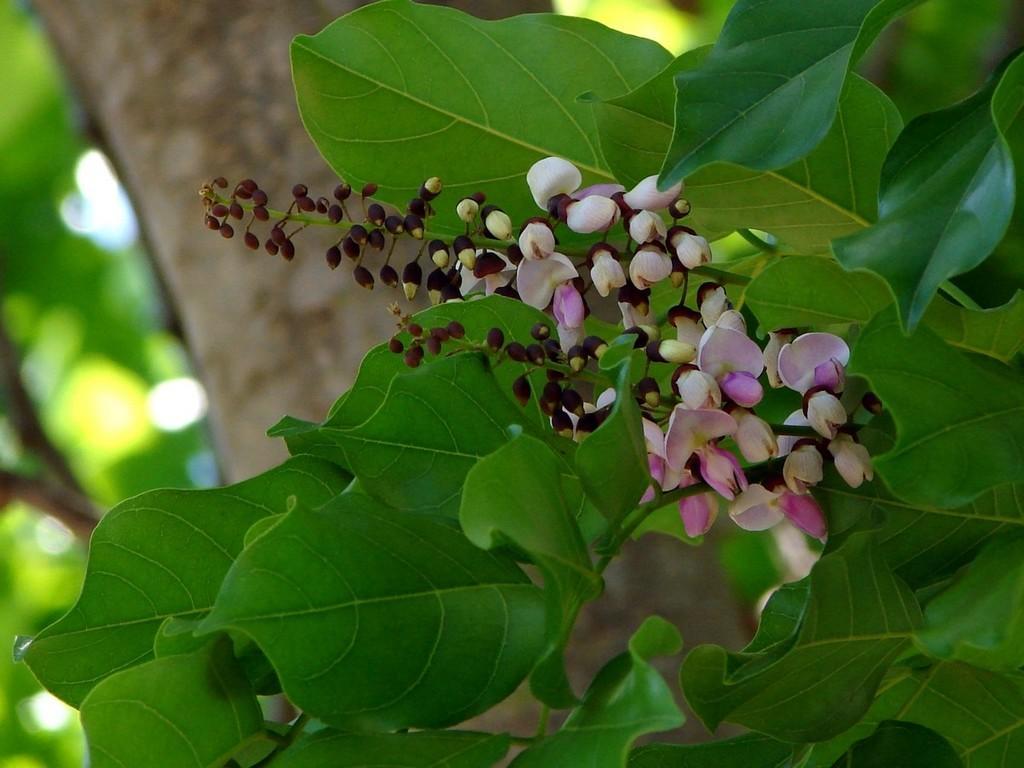Describe this image in one or two sentences. This picture shows a tree and we see leaves and flowers. 